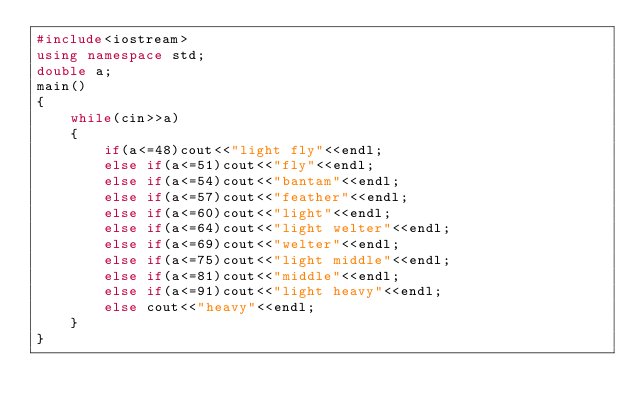<code> <loc_0><loc_0><loc_500><loc_500><_C++_>#include<iostream>
using namespace std;
double a;
main()
{
    while(cin>>a)
    {
        if(a<=48)cout<<"light fly"<<endl;
        else if(a<=51)cout<<"fly"<<endl;
        else if(a<=54)cout<<"bantam"<<endl;
        else if(a<=57)cout<<"feather"<<endl;
        else if(a<=60)cout<<"light"<<endl;
        else if(a<=64)cout<<"light welter"<<endl;
        else if(a<=69)cout<<"welter"<<endl;
        else if(a<=75)cout<<"light middle"<<endl;
        else if(a<=81)cout<<"middle"<<endl;
        else if(a<=91)cout<<"light heavy"<<endl;
        else cout<<"heavy"<<endl;
    }
}
</code> 